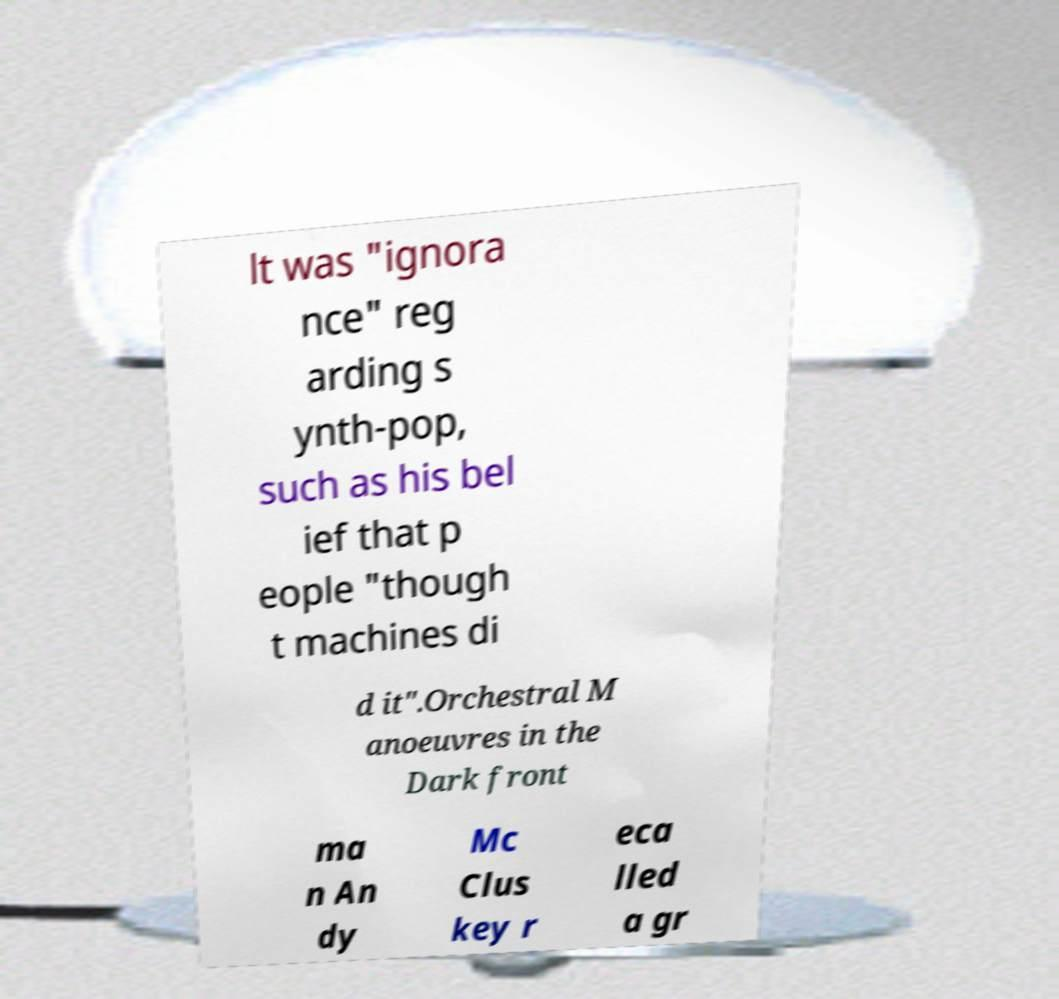What messages or text are displayed in this image? I need them in a readable, typed format. lt was "ignora nce" reg arding s ynth-pop, such as his bel ief that p eople "though t machines di d it".Orchestral M anoeuvres in the Dark front ma n An dy Mc Clus key r eca lled a gr 